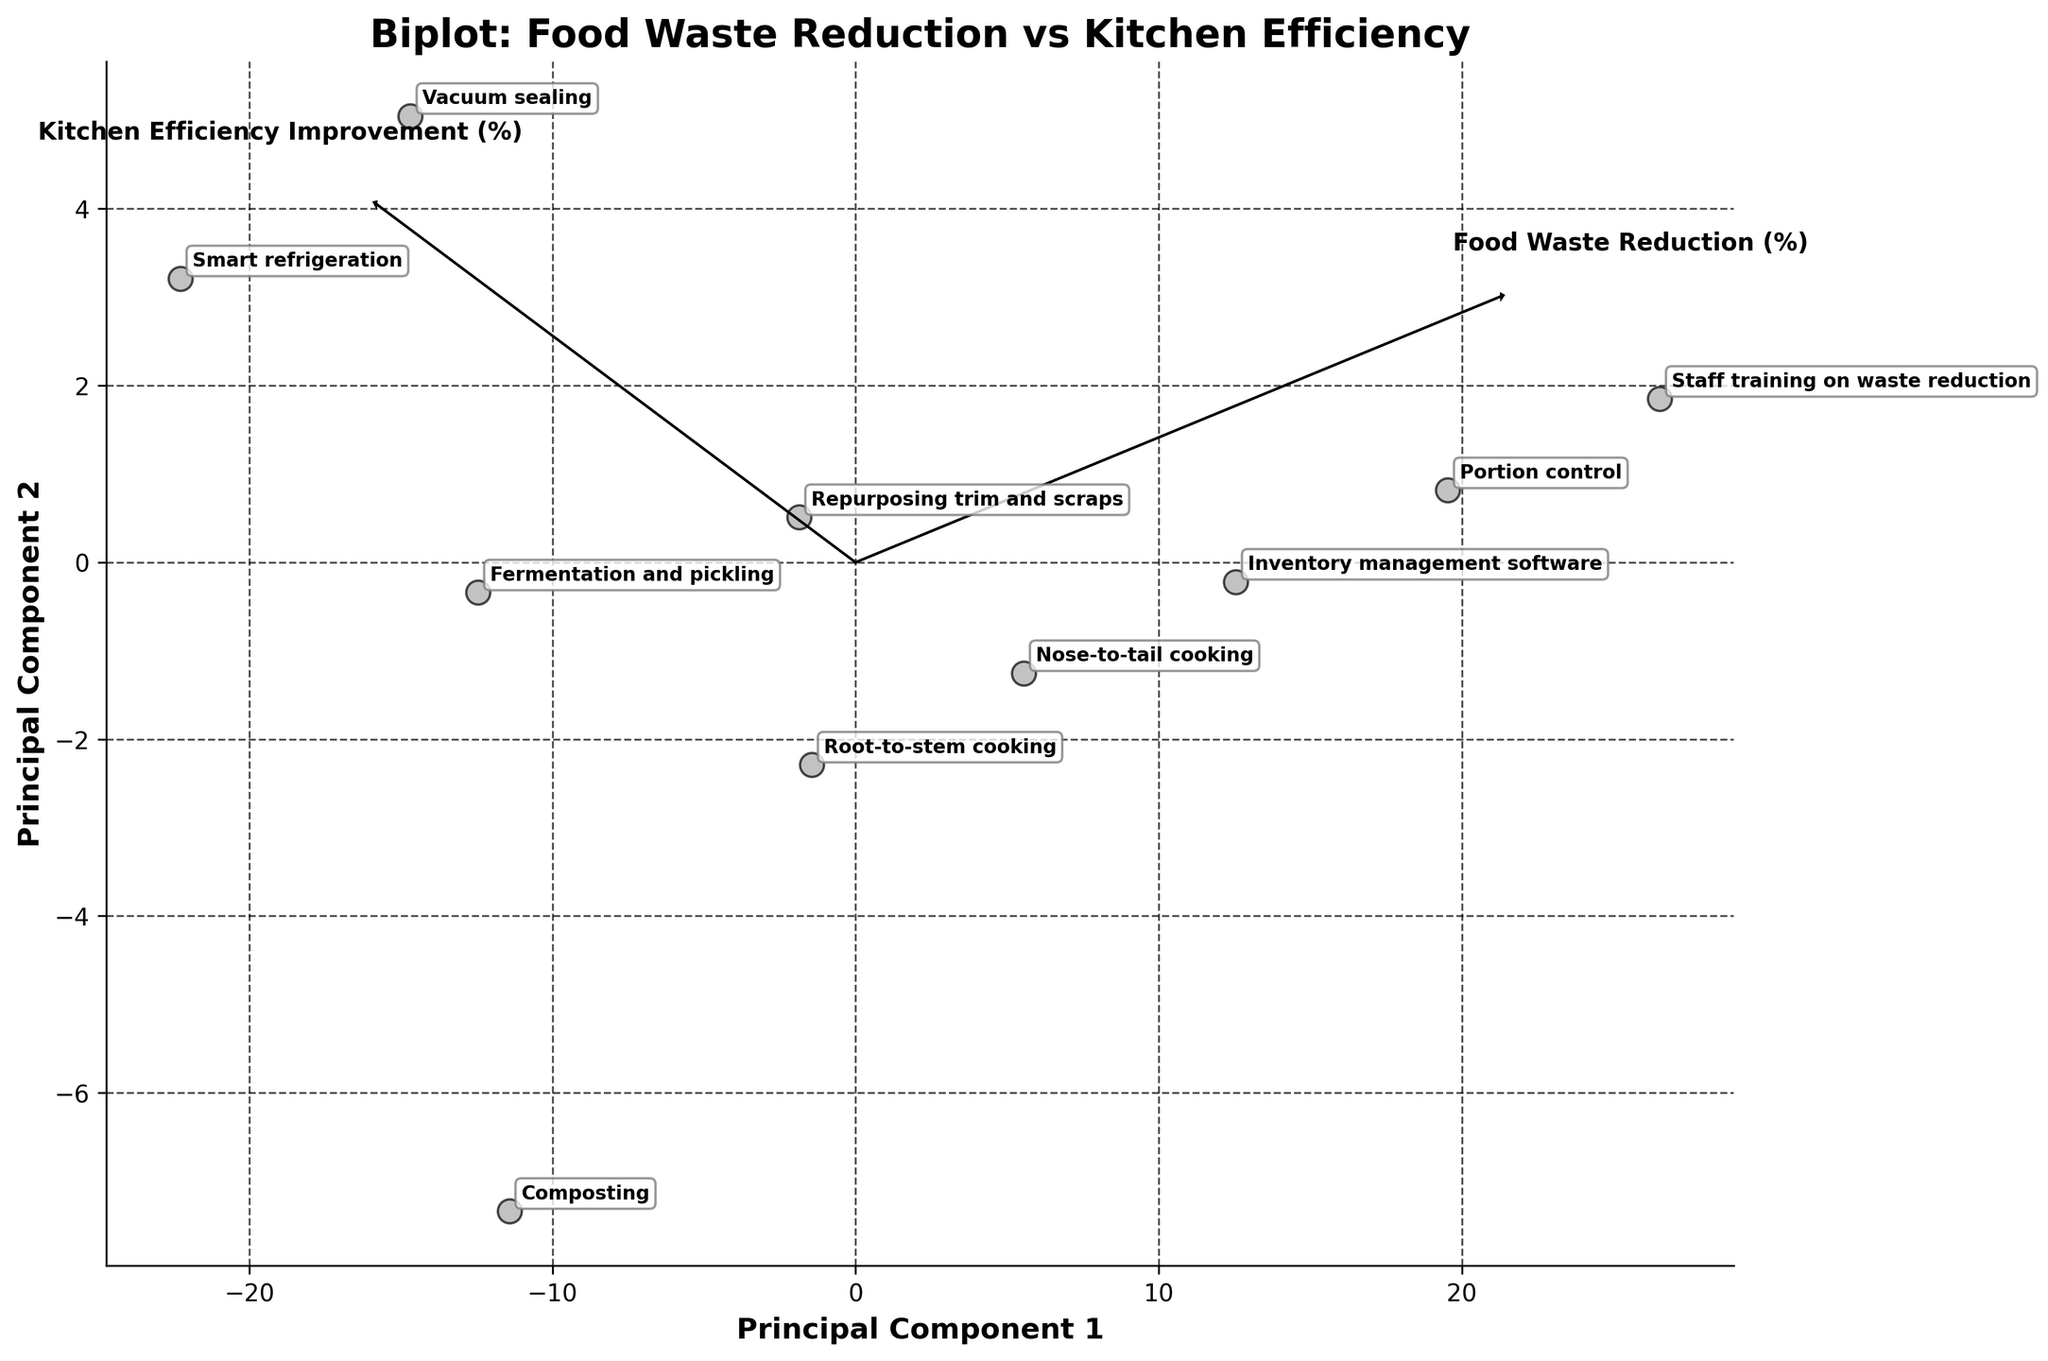What's the title of the figure? The title of a figure is usually found at the top of the plot and briefly describes the content or purpose of the visualization. The title here is "Biplot: Food Waste Reduction vs Kitchen Efficiency".
Answer: Biplot: Food Waste Reduction vs Kitchen Efficiency How many data points are plotted? Each label on the plot corresponds to a data point representing a technique. Counting these labels gives the total number of data points. There are 10 techniques labeled in the biplot.
Answer: 10 Which technique has the highest Food Waste Reduction (%)? By looking at the projection and identifying the data point labels, "Staff training on waste reduction" appears furthest along the "Food Waste Reduction (%)" axis.
Answer: Staff training on waste reduction What are the axes labels on the biplot? The axes are labeled, with the x-axis labeled "Principal Component 1" and the y-axis labeled "Principal Component 2".
Answer: Principal Component 1 and Principal Component 2 Is "Portion control" closer to Principal Component 1 or Principal Component 2? "Portion control" is positioned along the x-axis, indicating a stronger association with Principal Component 1. By identifying its placement, it's closer to Principal Component 1.
Answer: Principal Component 1 Which technique seems to provide the least improvement in kitchen efficiency improvement while reducing food waste? We look for the label closest to the origin but not along either of the axes' extremes. "Smart refrigeration" appears closer to both axes' origin, indicating it provides the least improvement in kitchen efficiency.
Answer: Smart refrigeration Comparing "Root-to-stem cooking" and "Vacuum sealing," which technique is more effective in reducing food waste? By locating the two labels, "Root-to-stem cooking" (40% reduction) is positioned higher on the "Food Waste Reduction" dimension compared to "Vacuum sealing" (25% reduction).
Answer: Root-to-stem cooking Which attributes (Food Waste Reduction % or Kitchen Efficiency Improvement %) vary more across techniques based on the spread along principal components? The spread along the axes shows the variation in attributes. A wider spread typically signifies greater variance. Here, the y-axis (Principal Component 2) appears more spread out, indicating greater variance in Kitchen Efficiency Improvement %.
Answer: Kitchen Efficiency Improvement % 